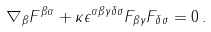<formula> <loc_0><loc_0><loc_500><loc_500>\nabla _ { \beta } F ^ { \beta \alpha } + \kappa \epsilon ^ { \alpha \beta \gamma \delta \sigma } F _ { \beta \gamma } F _ { \delta \sigma } = 0 \, .</formula> 